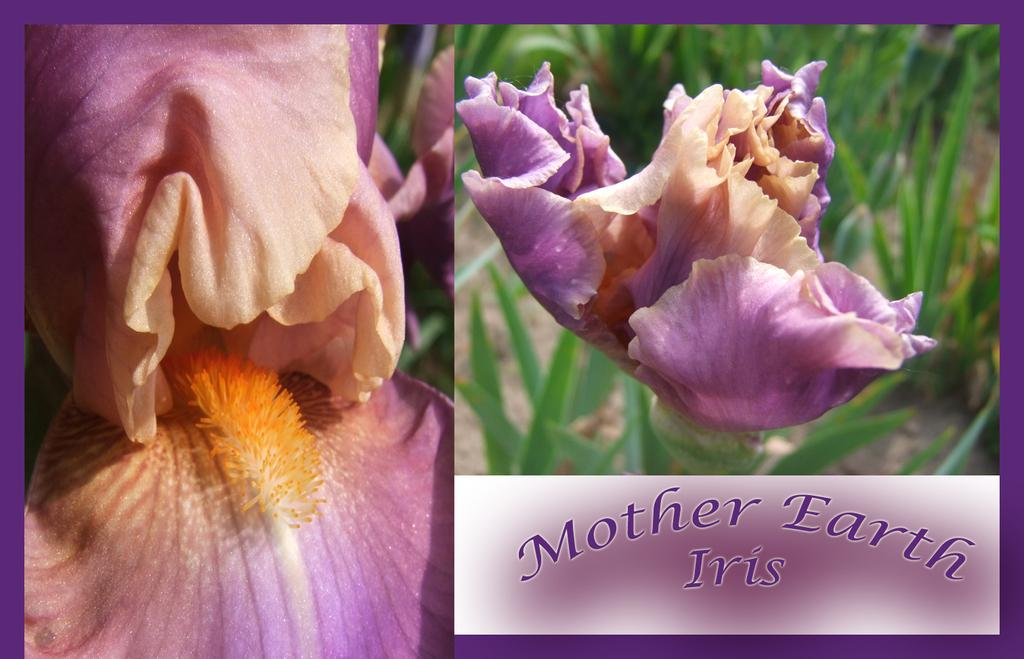What type of living organisms can be seen in the image? Flowers can be seen in the image. What type of silk fabric is draped over the flowers in the image? There is no silk fabric present in the image; it only features flowers. 